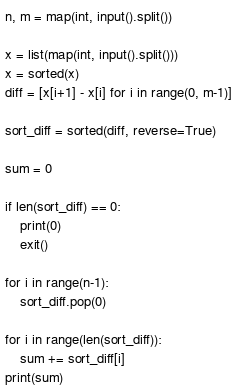<code> <loc_0><loc_0><loc_500><loc_500><_Python_>n, m = map(int, input().split())

x = list(map(int, input().split()))
x = sorted(x)
diff = [x[i+1] - x[i] for i in range(0, m-1)]

sort_diff = sorted(diff, reverse=True)

sum = 0

if len(sort_diff) == 0:
    print(0)
    exit()

for i in range(n-1):
    sort_diff.pop(0)

for i in range(len(sort_diff)):
    sum += sort_diff[i]
print(sum)</code> 